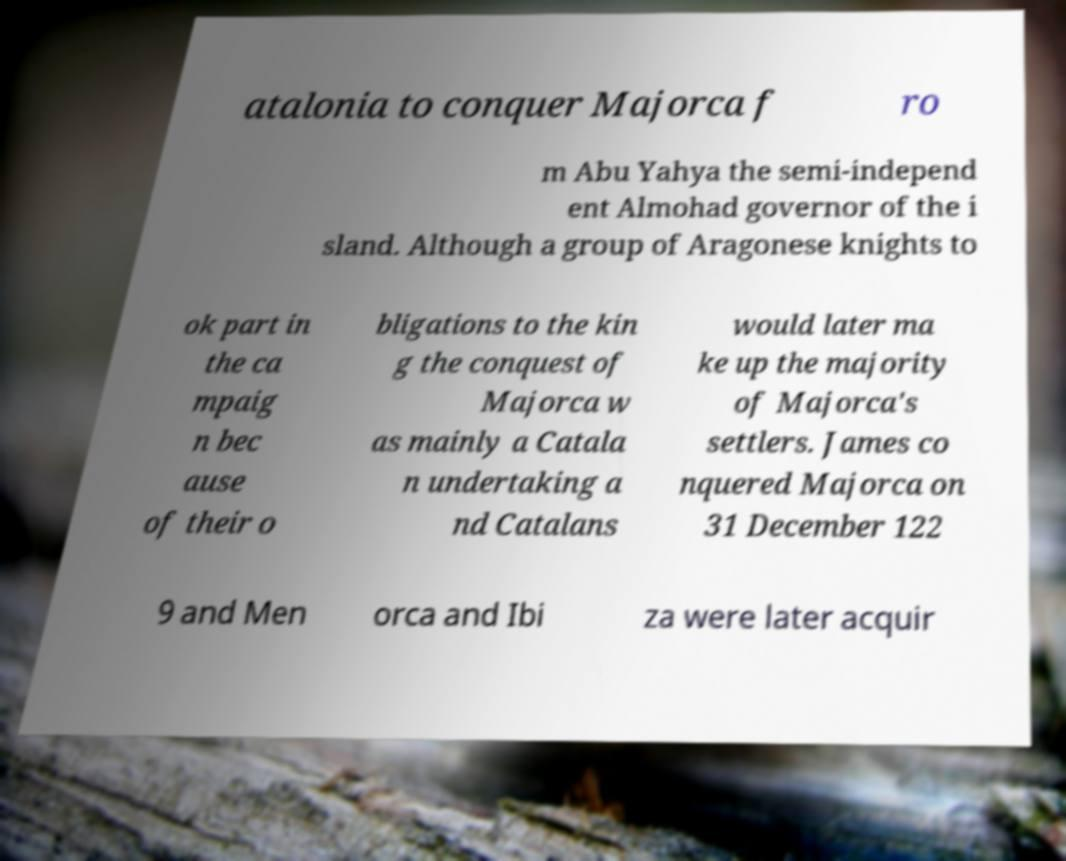There's text embedded in this image that I need extracted. Can you transcribe it verbatim? atalonia to conquer Majorca f ro m Abu Yahya the semi-independ ent Almohad governor of the i sland. Although a group of Aragonese knights to ok part in the ca mpaig n bec ause of their o bligations to the kin g the conquest of Majorca w as mainly a Catala n undertaking a nd Catalans would later ma ke up the majority of Majorca's settlers. James co nquered Majorca on 31 December 122 9 and Men orca and Ibi za were later acquir 